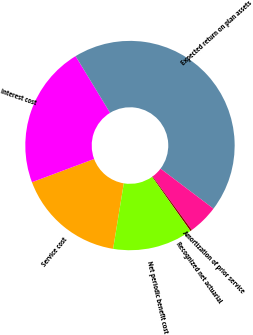<chart> <loc_0><loc_0><loc_500><loc_500><pie_chart><fcel>Service cost<fcel>Interest cost<fcel>Expected return on plan assets<fcel>Amortization of prior service<fcel>Recognized net actuarial<fcel>Net periodic benefit cost<nl><fcel>16.73%<fcel>22.0%<fcel>44.0%<fcel>4.64%<fcel>0.27%<fcel>12.36%<nl></chart> 